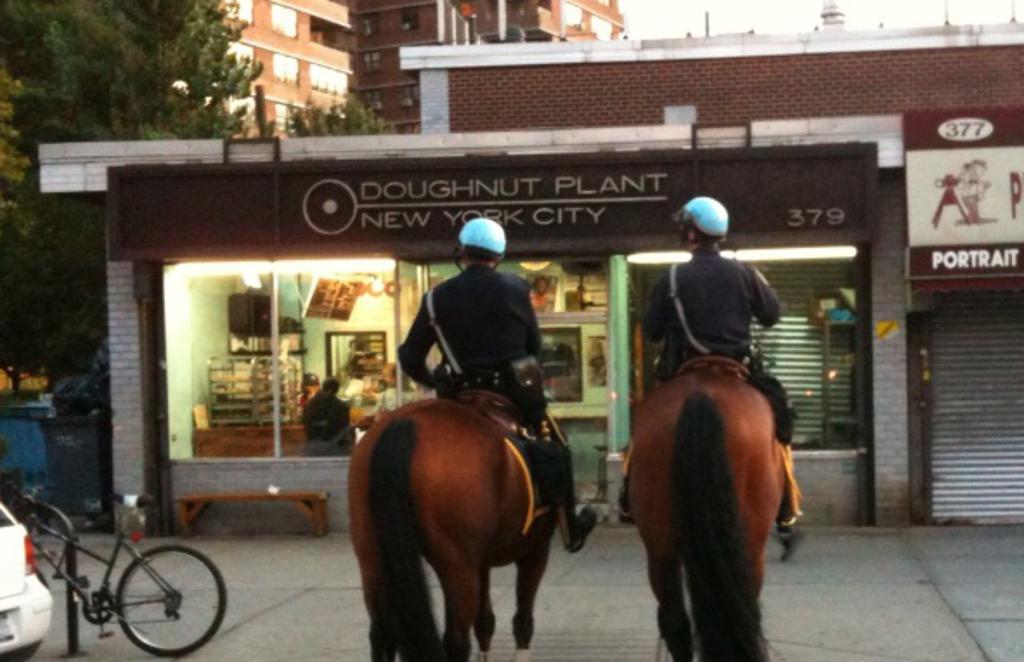Describe this image in one or two sentences. In the image there are two persons sitting on horses and on left side there is a cycle on footpath beside a car and in the front it seems to be a hotel and behind it there is building and a tree on left side. 